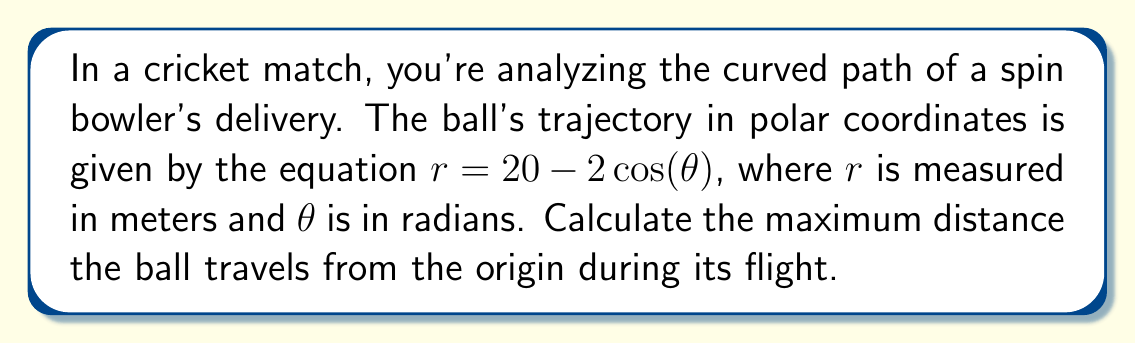Provide a solution to this math problem. To find the maximum distance the ball travels from the origin, we need to determine the maximum value of $r$ in the given equation.

1) The equation of the path is $r = 20 - 2\cos(\theta)$

2) To find the maximum value of $r$, we need to minimize the value of $\cos(\theta)$, as it has a negative coefficient.

3) The minimum value of $\cos(\theta)$ is -1, which occurs when $\theta = \pi$ radians or 180°.

4) Substituting this into our equation:

   $r_{max} = 20 - 2\cos(\pi)$
   $r_{max} = 20 - 2(-1)$
   $r_{max} = 20 + 2$
   $r_{max} = 22$

5) Therefore, the maximum distance the ball travels from the origin is 22 meters.

[asy]
import graph;
size(200);
real r(real t) {return 20-2*cos(t);}
draw(polargraph(r,0,2*pi),blue);
dot((22,0),red);
label("22m",(22,0),E);
draw(arc((0,0),5,0,360),dashed);
label("Origin",(0,0),SW);
[/asy]
Answer: The maximum distance the cricket ball travels from the origin is 22 meters. 